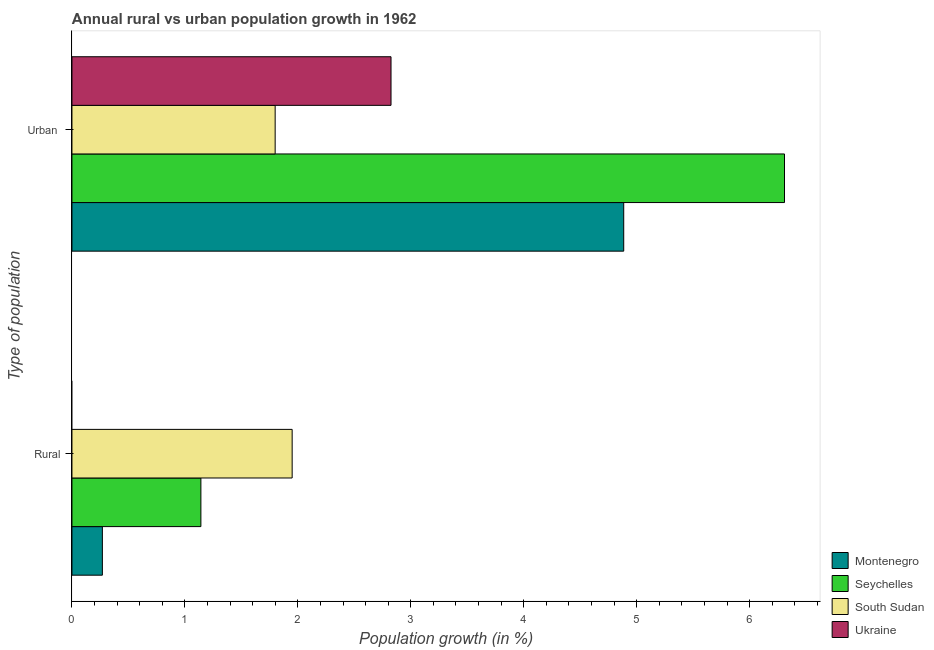How many different coloured bars are there?
Ensure brevity in your answer.  4. How many groups of bars are there?
Give a very brief answer. 2. Are the number of bars on each tick of the Y-axis equal?
Provide a short and direct response. No. What is the label of the 1st group of bars from the top?
Your answer should be very brief. Urban . What is the urban population growth in Seychelles?
Your answer should be very brief. 6.31. Across all countries, what is the maximum rural population growth?
Your response must be concise. 1.95. Across all countries, what is the minimum rural population growth?
Give a very brief answer. 0. In which country was the rural population growth maximum?
Provide a short and direct response. South Sudan. What is the total urban population growth in the graph?
Make the answer very short. 15.82. What is the difference between the urban population growth in Seychelles and that in Ukraine?
Your answer should be very brief. 3.48. What is the difference between the urban population growth in South Sudan and the rural population growth in Seychelles?
Your answer should be compact. 0.66. What is the average rural population growth per country?
Your response must be concise. 0.84. What is the difference between the rural population growth and urban population growth in Seychelles?
Offer a very short reply. -5.17. In how many countries, is the urban population growth greater than 2.6 %?
Provide a short and direct response. 3. What is the ratio of the urban population growth in Ukraine to that in South Sudan?
Keep it short and to the point. 1.57. Is the urban population growth in Montenegro less than that in Ukraine?
Your response must be concise. No. How many bars are there?
Provide a short and direct response. 7. Are all the bars in the graph horizontal?
Your answer should be very brief. Yes. How many countries are there in the graph?
Offer a terse response. 4. What is the difference between two consecutive major ticks on the X-axis?
Provide a short and direct response. 1. Does the graph contain any zero values?
Offer a terse response. Yes. Does the graph contain grids?
Ensure brevity in your answer.  No. Where does the legend appear in the graph?
Your answer should be very brief. Bottom right. How many legend labels are there?
Offer a very short reply. 4. How are the legend labels stacked?
Ensure brevity in your answer.  Vertical. What is the title of the graph?
Your answer should be compact. Annual rural vs urban population growth in 1962. What is the label or title of the X-axis?
Give a very brief answer. Population growth (in %). What is the label or title of the Y-axis?
Keep it short and to the point. Type of population. What is the Population growth (in %) of Montenegro in Rural?
Provide a short and direct response. 0.27. What is the Population growth (in %) of Seychelles in Rural?
Offer a terse response. 1.14. What is the Population growth (in %) in South Sudan in Rural?
Provide a succinct answer. 1.95. What is the Population growth (in %) in Ukraine in Rural?
Keep it short and to the point. 0. What is the Population growth (in %) in Montenegro in Urban ?
Give a very brief answer. 4.89. What is the Population growth (in %) of Seychelles in Urban ?
Provide a short and direct response. 6.31. What is the Population growth (in %) of South Sudan in Urban ?
Provide a short and direct response. 1.8. What is the Population growth (in %) in Ukraine in Urban ?
Offer a terse response. 2.82. Across all Type of population, what is the maximum Population growth (in %) in Montenegro?
Ensure brevity in your answer.  4.89. Across all Type of population, what is the maximum Population growth (in %) in Seychelles?
Offer a terse response. 6.31. Across all Type of population, what is the maximum Population growth (in %) in South Sudan?
Keep it short and to the point. 1.95. Across all Type of population, what is the maximum Population growth (in %) in Ukraine?
Keep it short and to the point. 2.82. Across all Type of population, what is the minimum Population growth (in %) of Montenegro?
Your answer should be compact. 0.27. Across all Type of population, what is the minimum Population growth (in %) of Seychelles?
Give a very brief answer. 1.14. Across all Type of population, what is the minimum Population growth (in %) of South Sudan?
Your answer should be very brief. 1.8. Across all Type of population, what is the minimum Population growth (in %) in Ukraine?
Ensure brevity in your answer.  0. What is the total Population growth (in %) of Montenegro in the graph?
Provide a succinct answer. 5.15. What is the total Population growth (in %) in Seychelles in the graph?
Keep it short and to the point. 7.45. What is the total Population growth (in %) in South Sudan in the graph?
Your answer should be compact. 3.75. What is the total Population growth (in %) of Ukraine in the graph?
Your answer should be compact. 2.82. What is the difference between the Population growth (in %) of Montenegro in Rural and that in Urban ?
Ensure brevity in your answer.  -4.62. What is the difference between the Population growth (in %) in Seychelles in Rural and that in Urban ?
Ensure brevity in your answer.  -5.17. What is the difference between the Population growth (in %) in South Sudan in Rural and that in Urban ?
Offer a terse response. 0.15. What is the difference between the Population growth (in %) of Montenegro in Rural and the Population growth (in %) of Seychelles in Urban ?
Provide a short and direct response. -6.04. What is the difference between the Population growth (in %) in Montenegro in Rural and the Population growth (in %) in South Sudan in Urban ?
Offer a terse response. -1.53. What is the difference between the Population growth (in %) in Montenegro in Rural and the Population growth (in %) in Ukraine in Urban ?
Your answer should be very brief. -2.56. What is the difference between the Population growth (in %) in Seychelles in Rural and the Population growth (in %) in South Sudan in Urban ?
Offer a very short reply. -0.66. What is the difference between the Population growth (in %) of Seychelles in Rural and the Population growth (in %) of Ukraine in Urban ?
Keep it short and to the point. -1.68. What is the difference between the Population growth (in %) in South Sudan in Rural and the Population growth (in %) in Ukraine in Urban ?
Provide a succinct answer. -0.88. What is the average Population growth (in %) in Montenegro per Type of population?
Make the answer very short. 2.58. What is the average Population growth (in %) of Seychelles per Type of population?
Make the answer very short. 3.73. What is the average Population growth (in %) of South Sudan per Type of population?
Your answer should be compact. 1.87. What is the average Population growth (in %) of Ukraine per Type of population?
Ensure brevity in your answer.  1.41. What is the difference between the Population growth (in %) of Montenegro and Population growth (in %) of Seychelles in Rural?
Ensure brevity in your answer.  -0.87. What is the difference between the Population growth (in %) of Montenegro and Population growth (in %) of South Sudan in Rural?
Ensure brevity in your answer.  -1.68. What is the difference between the Population growth (in %) in Seychelles and Population growth (in %) in South Sudan in Rural?
Your answer should be very brief. -0.81. What is the difference between the Population growth (in %) in Montenegro and Population growth (in %) in Seychelles in Urban ?
Offer a terse response. -1.42. What is the difference between the Population growth (in %) in Montenegro and Population growth (in %) in South Sudan in Urban ?
Provide a succinct answer. 3.09. What is the difference between the Population growth (in %) of Montenegro and Population growth (in %) of Ukraine in Urban ?
Provide a succinct answer. 2.06. What is the difference between the Population growth (in %) in Seychelles and Population growth (in %) in South Sudan in Urban ?
Offer a very short reply. 4.51. What is the difference between the Population growth (in %) of Seychelles and Population growth (in %) of Ukraine in Urban ?
Your response must be concise. 3.48. What is the difference between the Population growth (in %) in South Sudan and Population growth (in %) in Ukraine in Urban ?
Make the answer very short. -1.03. What is the ratio of the Population growth (in %) in Montenegro in Rural to that in Urban ?
Provide a short and direct response. 0.06. What is the ratio of the Population growth (in %) of Seychelles in Rural to that in Urban ?
Your answer should be very brief. 0.18. What is the ratio of the Population growth (in %) in South Sudan in Rural to that in Urban ?
Ensure brevity in your answer.  1.08. What is the difference between the highest and the second highest Population growth (in %) of Montenegro?
Keep it short and to the point. 4.62. What is the difference between the highest and the second highest Population growth (in %) in Seychelles?
Ensure brevity in your answer.  5.17. What is the difference between the highest and the second highest Population growth (in %) of South Sudan?
Provide a short and direct response. 0.15. What is the difference between the highest and the lowest Population growth (in %) in Montenegro?
Your answer should be very brief. 4.62. What is the difference between the highest and the lowest Population growth (in %) in Seychelles?
Provide a succinct answer. 5.17. What is the difference between the highest and the lowest Population growth (in %) in South Sudan?
Keep it short and to the point. 0.15. What is the difference between the highest and the lowest Population growth (in %) of Ukraine?
Make the answer very short. 2.82. 